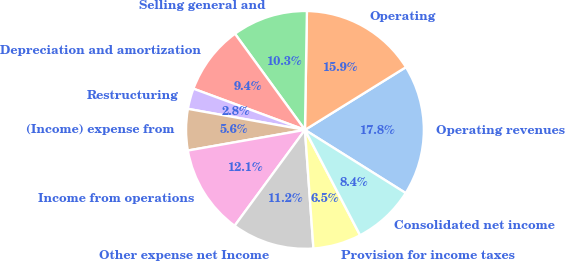Convert chart. <chart><loc_0><loc_0><loc_500><loc_500><pie_chart><fcel>Operating revenues<fcel>Operating<fcel>Selling general and<fcel>Depreciation and amortization<fcel>Restructuring<fcel>(Income) expense from<fcel>Income from operations<fcel>Other expense net Income<fcel>Provision for income taxes<fcel>Consolidated net income<nl><fcel>17.76%<fcel>15.89%<fcel>10.28%<fcel>9.35%<fcel>2.8%<fcel>5.61%<fcel>12.15%<fcel>11.21%<fcel>6.54%<fcel>8.41%<nl></chart> 